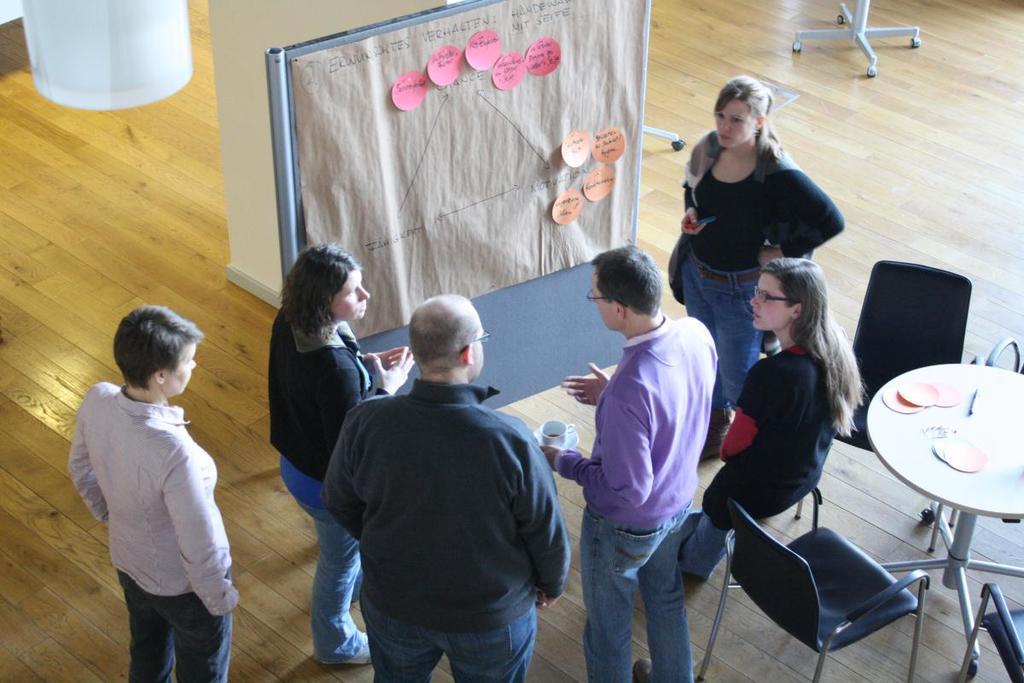Could you give a brief overview of what you see in this image? There is a group of persons standing as we can see at the bottom of this image. There is one table and some chairs are present on the right side of this image, and there is a floor in the background. There is a board attached with some papers at the top of this image, and there is a pillar beside to this board. 